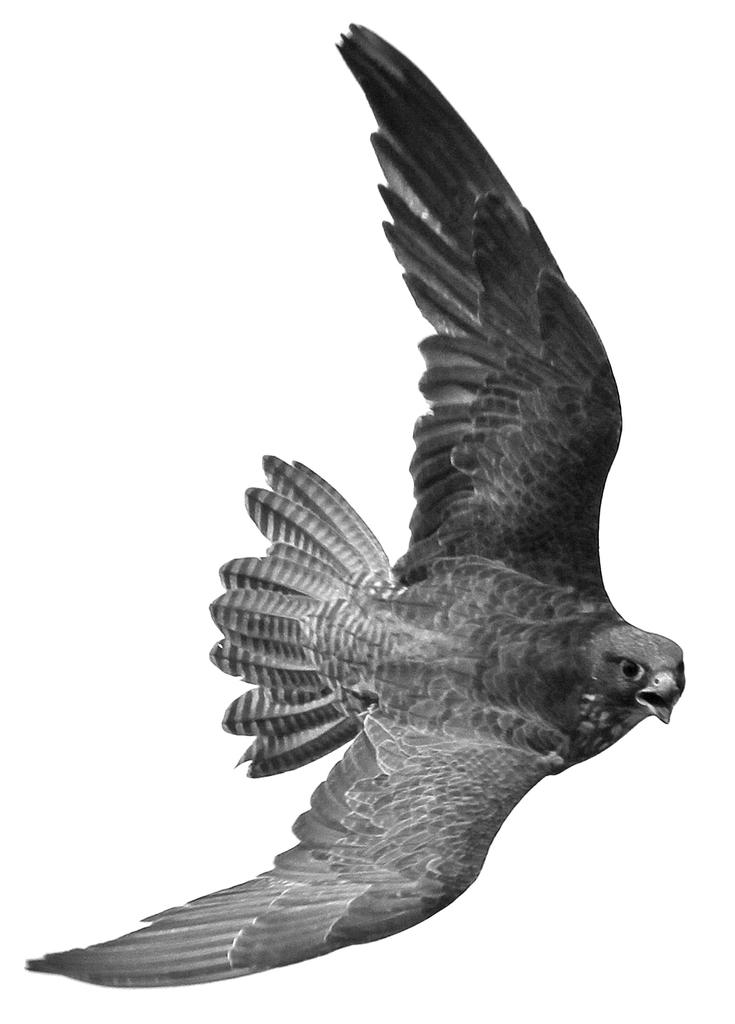What is the main subject of the image? There is a bird flying in the image. What can be observed about the bird's movement? The bird is flying in the image. What is the color of the background in the image? The background of the image is white. What type of fork can be seen in the bird's beak in the image? There is no fork present in the image; it features a bird flying against a white background. 